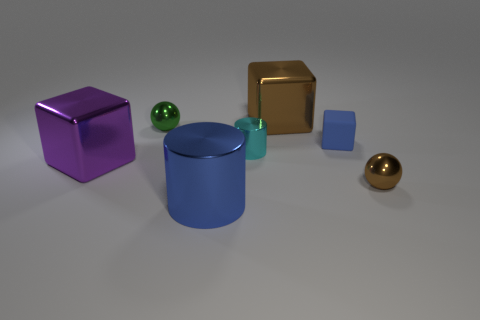Add 1 large purple objects. How many objects exist? 8 Subtract all blocks. How many objects are left? 4 Add 1 blue matte blocks. How many blue matte blocks are left? 2 Add 2 brown things. How many brown things exist? 4 Subtract 0 yellow cylinders. How many objects are left? 7 Subtract all tiny brown matte balls. Subtract all large cylinders. How many objects are left? 6 